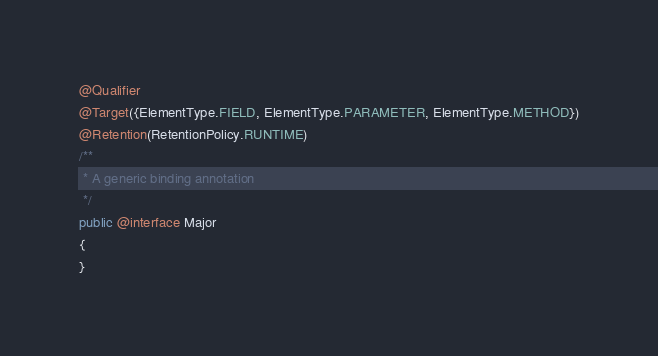Convert code to text. <code><loc_0><loc_0><loc_500><loc_500><_Java_>
@Qualifier
@Target({ElementType.FIELD, ElementType.PARAMETER, ElementType.METHOD})
@Retention(RetentionPolicy.RUNTIME)
/**
 * A generic binding annotation
 */
public @interface Major
{
}
</code> 